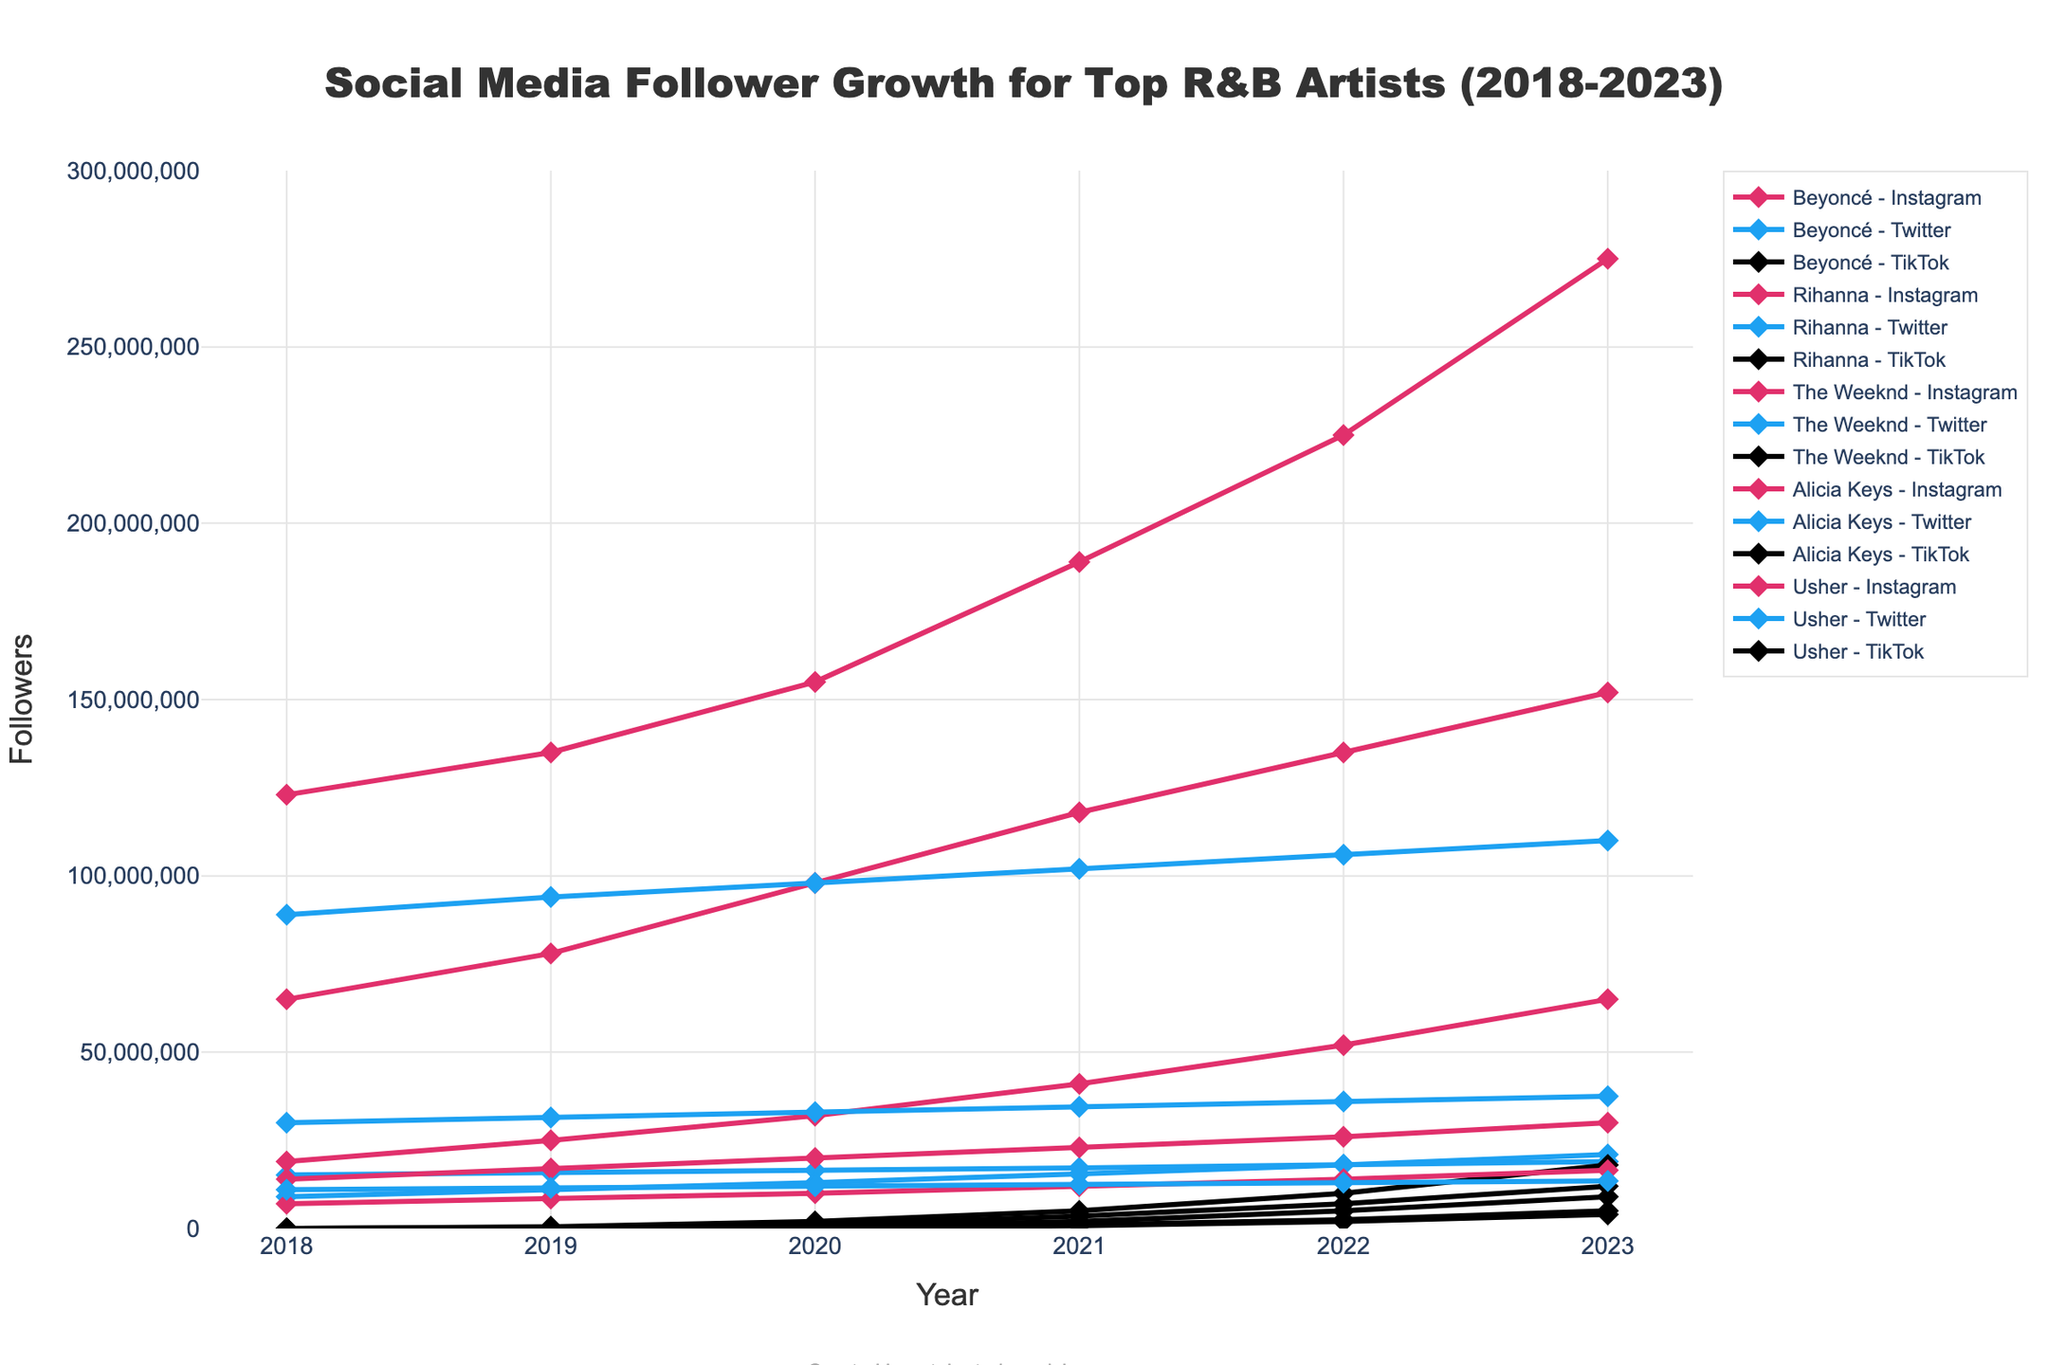What's the highest number of Instagram followers for Beyoncé in the given period? Beyoncé's Instagram followers in 2023 is the highest value on the chart for her social media accounts across different years and platforms. The data point for 2023 shows 275,000,000 followers.
Answer: 275,000,000 Which artist had more Twitter followers in 2022, Rihanna or The Weeknd? By looking at the Twitter line for both artists in 2022, Rihanna had 106,000,000 Twitter followers while The Weeknd had 18,000,000. Therefore, Rihanna had more Twitter followers in 2022.
Answer: Rihanna How did The Weeknd's TikTok followers change from 2020 to 2023? The Weeknd's TikTok followers grew from 2,000,000 in 2020 to 18,000,000 in 2023. To find the increase, subtract the former from the latter: 18,000,000 - 2,000,000 = 16,000,000.
Answer: Increase by 16,000,000 What is the overall trend for Alicia Keys' Instagram followers from 2018 to 2023? Alicia Keys' Instagram followers steadily increased each year from 14,000,000 in 2018 to 30,000,000 in 2023, indicating a consistent upward trend.
Answer: Consistently increasing Compare the growth in TikTok followers of Rihanna and Usher from 2021 to 2023. Who had a greater increase? Rihanna's TikTok followers grew from 2,000,000 in 2021 to 9,000,000 in 2023, increasing by 7,000,000. Usher's TikTok followers grew from 800,000 in 2021 to 4,000,000 in 2023, increasing by 3,200,000. Therefore, Rihanna had a greater increase.
Answer: Rihanna By how many followers did Beyoncé's Instagram followers increase between 2018 to 2023? Beyoncé’s Instagram followers increased from 123,000,000 in 2018 to 275,000,000 in 2023. The increase can be calculated by subtracting the starting value from the ending value: 275,000,000 - 123,000,000 = 152,000,000.
Answer: 152,000,000 Among the top 5 artists, who had the fewest TikTok followers in 2023? By observing the chart at the 2023 data points for TikTok followers, Usher had the fewest TikTok followers among the five artists with just 4,000,000 followers.
Answer: Usher Which platform saw the greatest increase in followers for Rihanna between 2018 and 2023? Rihanna’s Instagram followers increased from 65,000,000 in 2018 to 152,000,000 in 2023, a growth of 87,000,000. Rihanna’s Twitter followers increased from 89,000,000 in 2018 to 110,000,000 in 2023, a growth of 21,000,000. Her TikTok followers started from 0 in 2018 and grew to 9,000,000 in 2023. The Instagram platform saw the greatest increase.
Answer: Instagram 